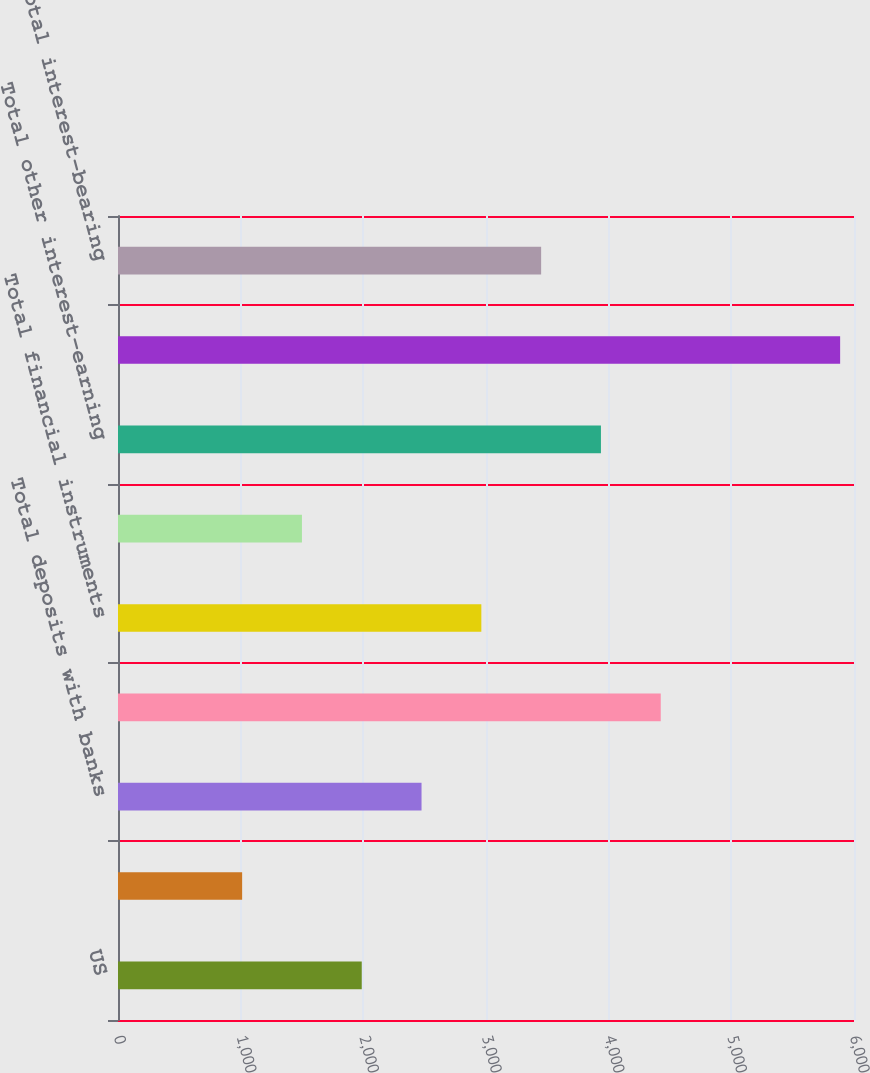Convert chart. <chart><loc_0><loc_0><loc_500><loc_500><bar_chart><fcel>US<fcel>Non-US<fcel>Total deposits with banks<fcel>Total collateralized<fcel>Total financial instruments<fcel>Total loans receivable<fcel>Total other interest-earning<fcel>Change in interest income<fcel>Total interest-bearing<nl><fcel>1987<fcel>1012<fcel>2474.5<fcel>4424.5<fcel>2962<fcel>1499.5<fcel>3937<fcel>5887<fcel>3449.5<nl></chart> 